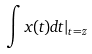Convert formula to latex. <formula><loc_0><loc_0><loc_500><loc_500>\int x ( t ) d t | _ { t = z }</formula> 